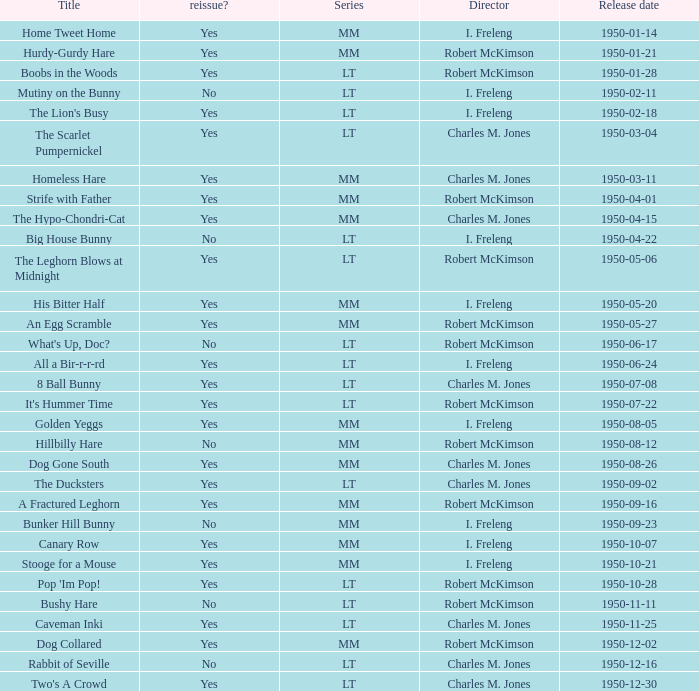Who directed Bunker Hill Bunny? I. Freleng. 